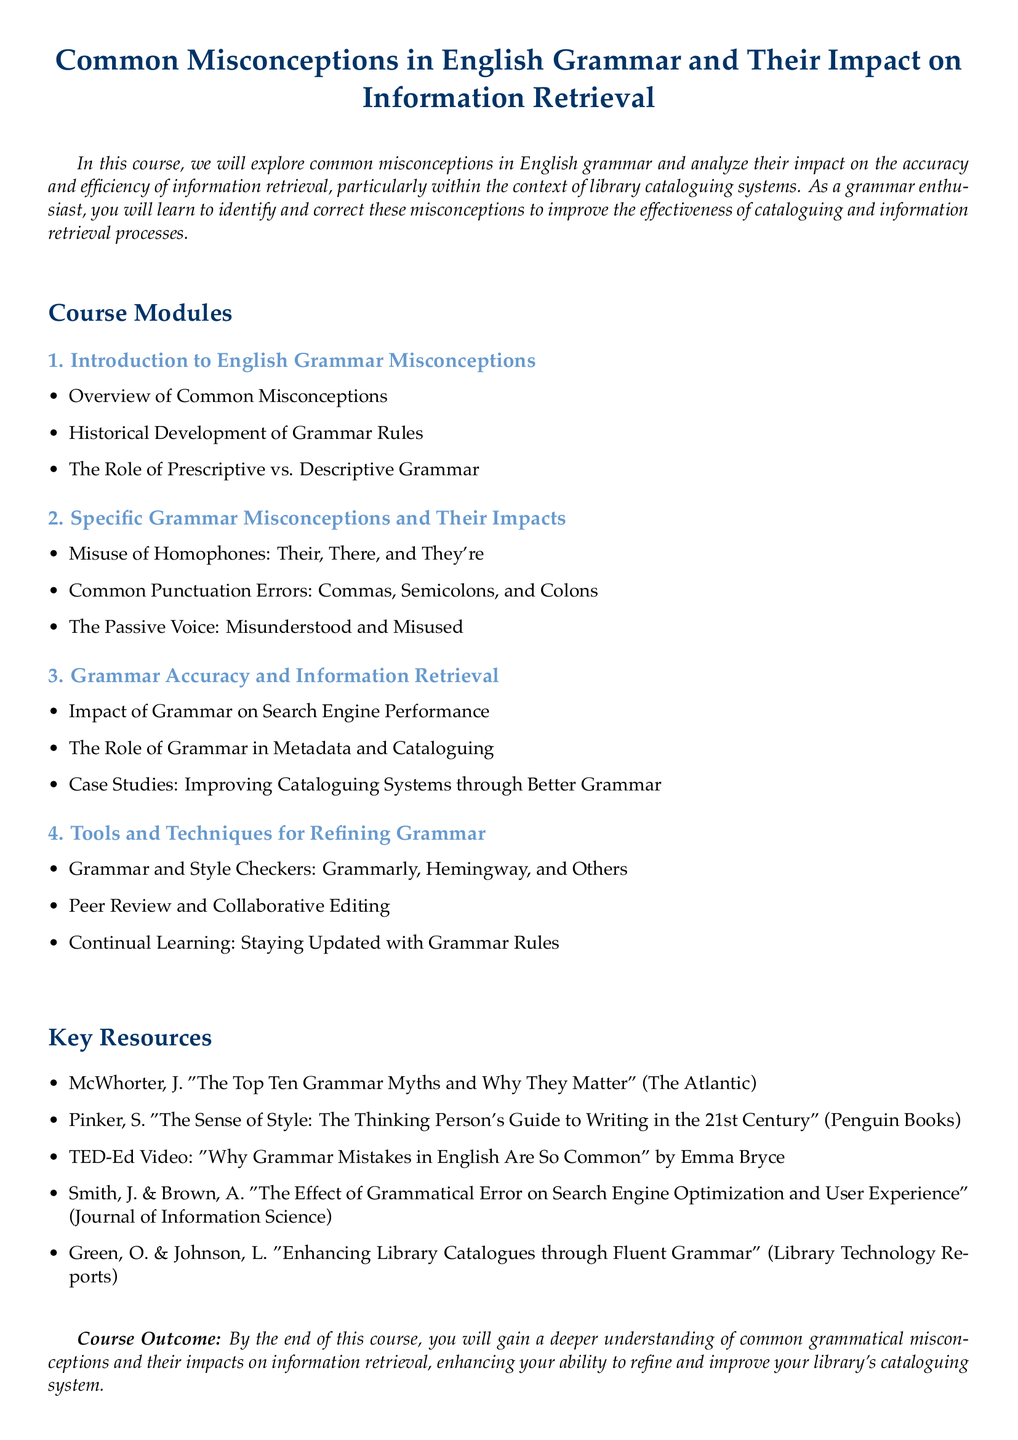What is the main focus of the course? The main focus of the course is to explore common misconceptions in English grammar and analyze their impact on the accuracy and efficiency of information retrieval.
Answer: English grammar misconceptions and information retrieval How many modules are in the course? The document lists four distinct modules within the course structure.
Answer: Four Which module addresses the misuse of homophones? The module that discusses the misuse of homophones is titled "Specific Grammar Misconceptions and Their Impacts."
Answer: Specific Grammar Misconceptions and Their Impacts Who is one of the authors of the key resource about grammatical error impacts? One of the authors mentioned in the key resources is Smith.
Answer: Smith What is one tool mentioned for refining grammar? One tool listed in the document for refining grammar is Grammarly.
Answer: Grammarly Why is the passive voice included in the syllabus? The passive voice is included as it is often misunderstood and misused, which is significant for information retrieval.
Answer: Misunderstood and Misused What is one outcome of the course? One outcome mentioned is gaining a deeper understanding of common grammatical misconceptions.
Answer: Deeper understanding of common grammatical misconceptions 